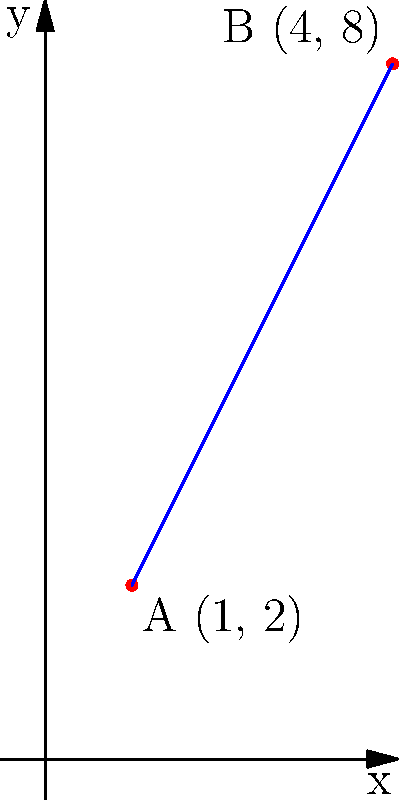As part of your meditation and yoga routine, you're planning to visit two different yoga studios in your city. Studio A is located at coordinates (1, 2), and Studio B is at (4, 8) on a city map. Calculate the slope of the line connecting these two studios. To find the slope of the line connecting two points, we use the slope formula:

$$ m = \frac{y_2 - y_1}{x_2 - x_1} $$

Where $(x_1, y_1)$ is the first point and $(x_2, y_2)$ is the second point.

Given:
- Studio A: $(x_1, y_1) = (1, 2)$
- Studio B: $(x_2, y_2) = (4, 8)$

Let's plug these values into the formula:

$$ m = \frac{8 - 2}{4 - 1} = \frac{6}{3} $$

Simplifying the fraction:

$$ m = 2 $$

Therefore, the slope of the line connecting the two yoga studios is 2.

This positive slope indicates that as you move from Studio A to Studio B, you're going "up" on the map, which aligns with the coordinates given (moving from a lower y-value to a higher y-value).
Answer: 2 